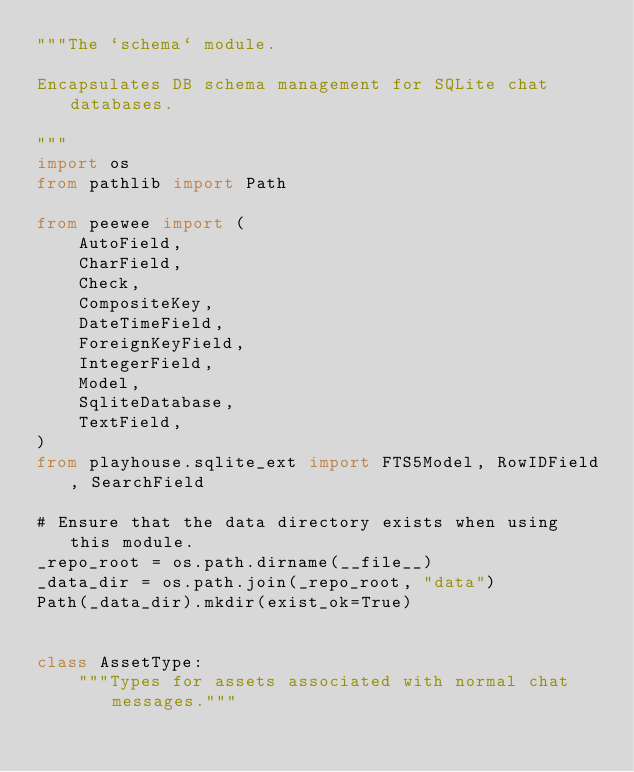<code> <loc_0><loc_0><loc_500><loc_500><_Python_>"""The `schema` module.

Encapsulates DB schema management for SQLite chat databases.

"""
import os
from pathlib import Path

from peewee import (
    AutoField,
    CharField,
    Check,
    CompositeKey,
    DateTimeField,
    ForeignKeyField,
    IntegerField,
    Model,
    SqliteDatabase,
    TextField,
)
from playhouse.sqlite_ext import FTS5Model, RowIDField, SearchField

# Ensure that the data directory exists when using this module.
_repo_root = os.path.dirname(__file__)
_data_dir = os.path.join(_repo_root, "data")
Path(_data_dir).mkdir(exist_ok=True)


class AssetType:
    """Types for assets associated with normal chat messages."""
</code> 